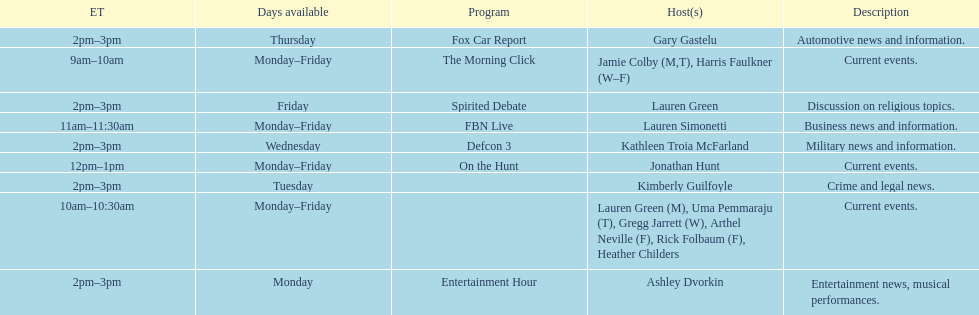How many days during the week does the show fbn live air? 5. 